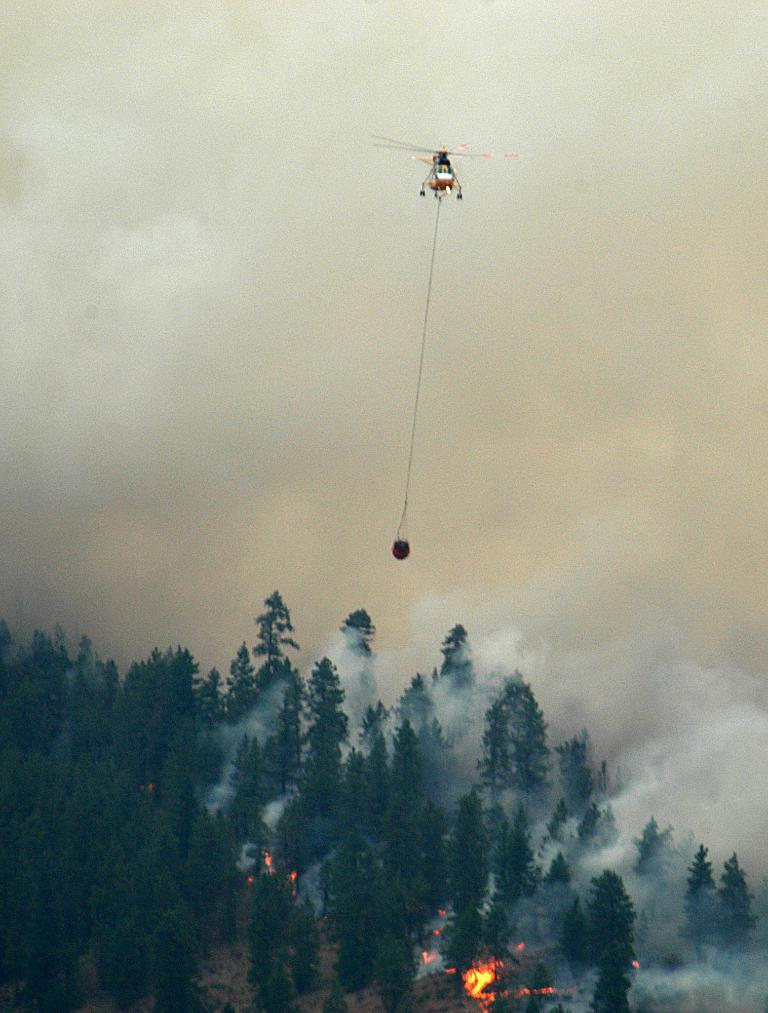What is tied with a rope to the airplane in the image? There is an object tied with a rope to the airplane in the image. What is the position of the airplane in the image? The airplane is in the air. What type of natural vegetation can be seen in the image? Trees are visible in the image. What is the result of the fire in the image? Smoke is present in the image as a result of the fire. What part of the environment is visible in the image? The sky is visible in the image. Can you tell me how many balloons are tied to the gate in the image? There are no balloons or gates present in the image. What type of creature is shaking the tree in the image? There is no creature shaking the tree in the image; the trees are stationary. 